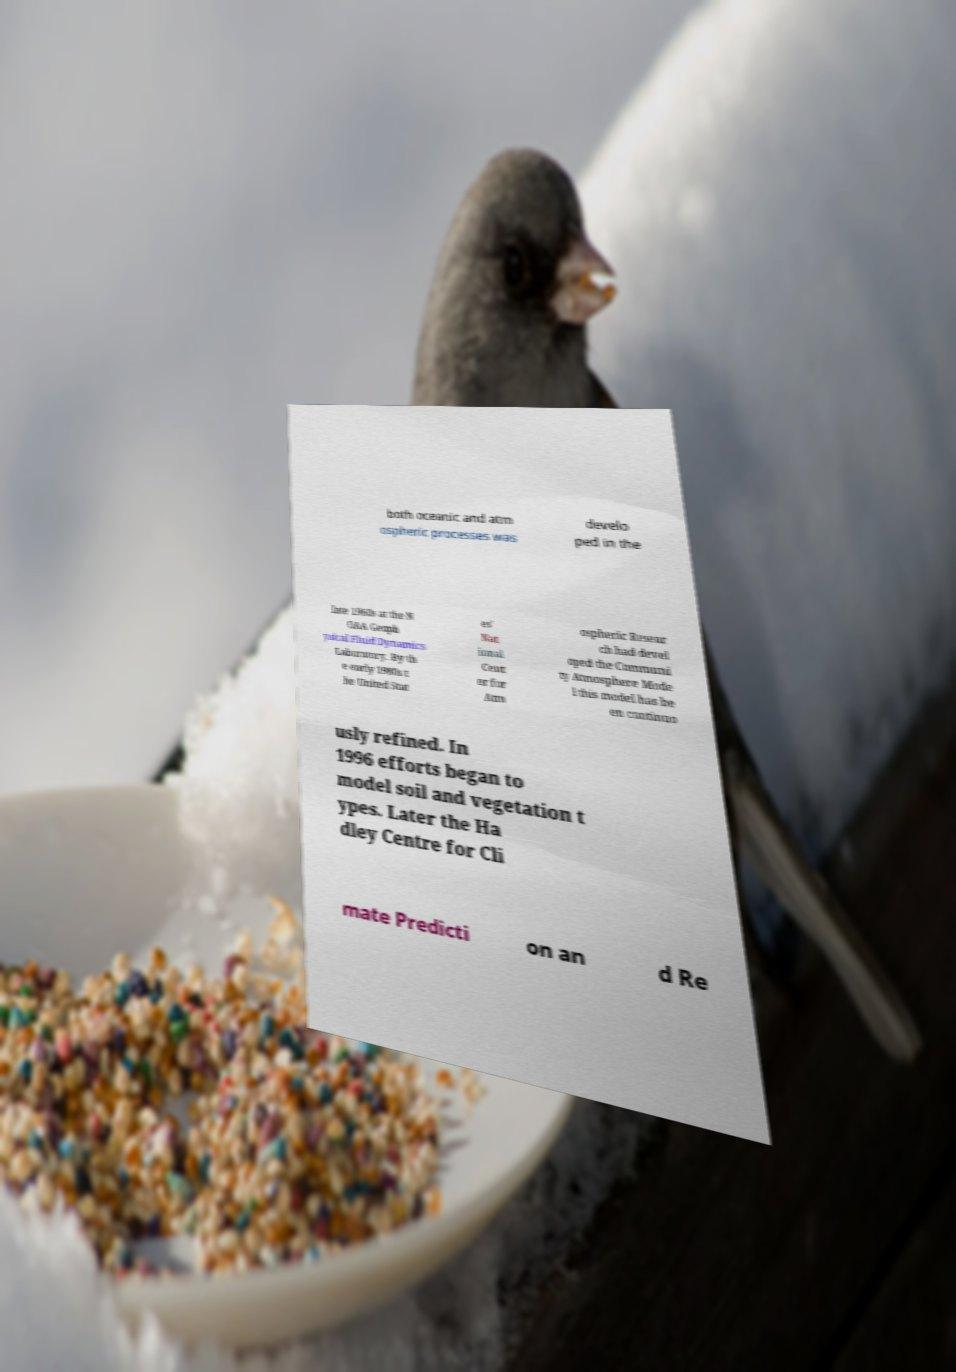What messages or text are displayed in this image? I need them in a readable, typed format. both oceanic and atm ospheric processes was develo ped in the late 1960s at the N OAA Geoph ysical Fluid Dynamics Laboratory. By th e early 1980s t he United Stat es' Nat ional Cent er for Atm ospheric Resear ch had devel oped the Communi ty Atmosphere Mode l this model has be en continuo usly refined. In 1996 efforts began to model soil and vegetation t ypes. Later the Ha dley Centre for Cli mate Predicti on an d Re 